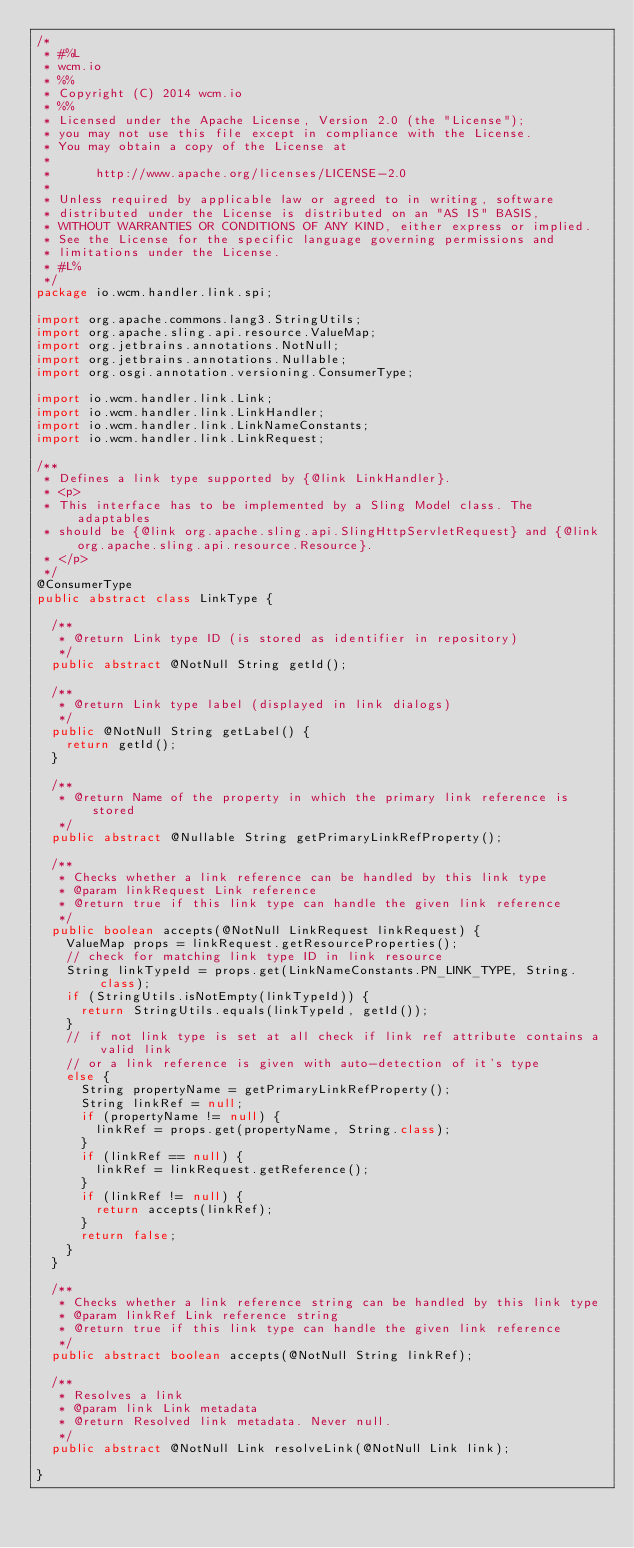Convert code to text. <code><loc_0><loc_0><loc_500><loc_500><_Java_>/*
 * #%L
 * wcm.io
 * %%
 * Copyright (C) 2014 wcm.io
 * %%
 * Licensed under the Apache License, Version 2.0 (the "License");
 * you may not use this file except in compliance with the License.
 * You may obtain a copy of the License at
 *
 *      http://www.apache.org/licenses/LICENSE-2.0
 *
 * Unless required by applicable law or agreed to in writing, software
 * distributed under the License is distributed on an "AS IS" BASIS,
 * WITHOUT WARRANTIES OR CONDITIONS OF ANY KIND, either express or implied.
 * See the License for the specific language governing permissions and
 * limitations under the License.
 * #L%
 */
package io.wcm.handler.link.spi;

import org.apache.commons.lang3.StringUtils;
import org.apache.sling.api.resource.ValueMap;
import org.jetbrains.annotations.NotNull;
import org.jetbrains.annotations.Nullable;
import org.osgi.annotation.versioning.ConsumerType;

import io.wcm.handler.link.Link;
import io.wcm.handler.link.LinkHandler;
import io.wcm.handler.link.LinkNameConstants;
import io.wcm.handler.link.LinkRequest;

/**
 * Defines a link type supported by {@link LinkHandler}.
 * <p>
 * This interface has to be implemented by a Sling Model class. The adaptables
 * should be {@link org.apache.sling.api.SlingHttpServletRequest} and {@link org.apache.sling.api.resource.Resource}.
 * </p>
 */
@ConsumerType
public abstract class LinkType {

  /**
   * @return Link type ID (is stored as identifier in repository)
   */
  public abstract @NotNull String getId();

  /**
   * @return Link type label (displayed in link dialogs)
   */
  public @NotNull String getLabel() {
    return getId();
  }

  /**
   * @return Name of the property in which the primary link reference is stored
   */
  public abstract @Nullable String getPrimaryLinkRefProperty();

  /**
   * Checks whether a link reference can be handled by this link type
   * @param linkRequest Link reference
   * @return true if this link type can handle the given link reference
   */
  public boolean accepts(@NotNull LinkRequest linkRequest) {
    ValueMap props = linkRequest.getResourceProperties();
    // check for matching link type ID in link resource
    String linkTypeId = props.get(LinkNameConstants.PN_LINK_TYPE, String.class);
    if (StringUtils.isNotEmpty(linkTypeId)) {
      return StringUtils.equals(linkTypeId, getId());
    }
    // if not link type is set at all check if link ref attribute contains a valid link
    // or a link reference is given with auto-detection of it's type
    else {
      String propertyName = getPrimaryLinkRefProperty();
      String linkRef = null;
      if (propertyName != null) {
        linkRef = props.get(propertyName, String.class);
      }
      if (linkRef == null) {
        linkRef = linkRequest.getReference();
      }
      if (linkRef != null) {
        return accepts(linkRef);
      }
      return false;
    }
  }

  /**
   * Checks whether a link reference string can be handled by this link type
   * @param linkRef Link reference string
   * @return true if this link type can handle the given link reference
   */
  public abstract boolean accepts(@NotNull String linkRef);

  /**
   * Resolves a link
   * @param link Link metadata
   * @return Resolved link metadata. Never null.
   */
  public abstract @NotNull Link resolveLink(@NotNull Link link);

}
</code> 